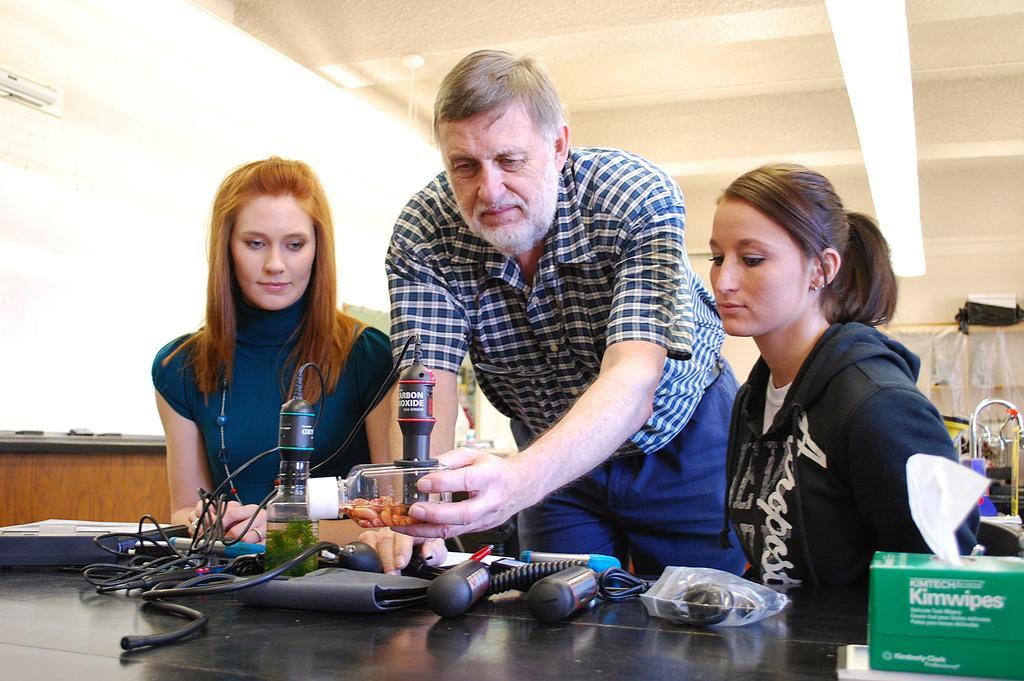Describe this image in one or two sentences. In this picture we can see a man and two women here, there is a table in front of them, we can see some wires and equipment present on the table, at the right bottom we can see a wipe box, we can see a light at the top of the picture, we can see a wall here. 